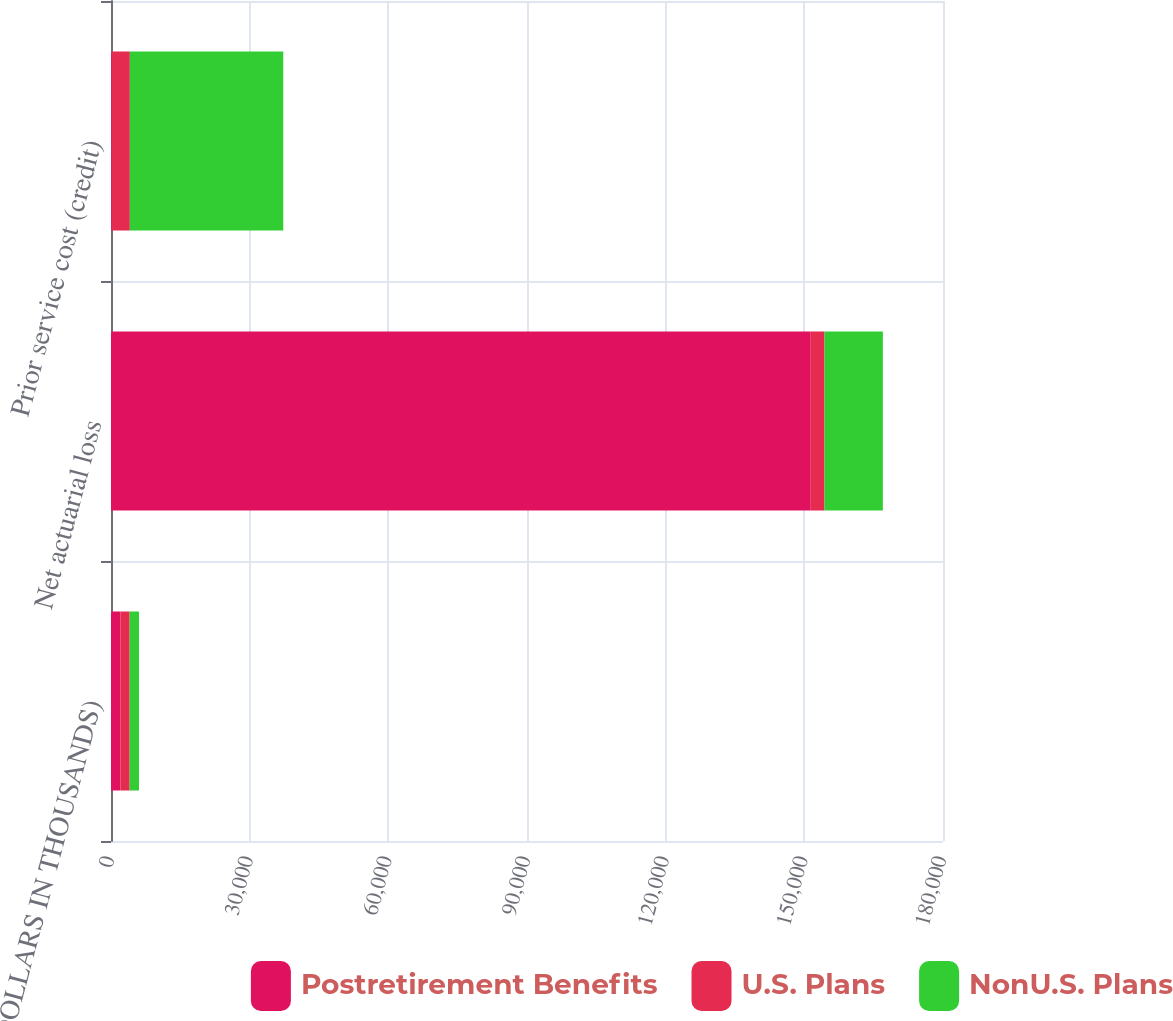<chart> <loc_0><loc_0><loc_500><loc_500><stacked_bar_chart><ecel><fcel>(DOLLARS IN THOUSANDS)<fcel>Net actuarial loss<fcel>Prior service cost (credit)<nl><fcel>Postretirement Benefits<fcel>2018<fcel>151389<fcel>151<nl><fcel>U.S. Plans<fcel>2018<fcel>2972<fcel>3926<nl><fcel>NonU.S. Plans<fcel>2018<fcel>12627<fcel>33189<nl></chart> 